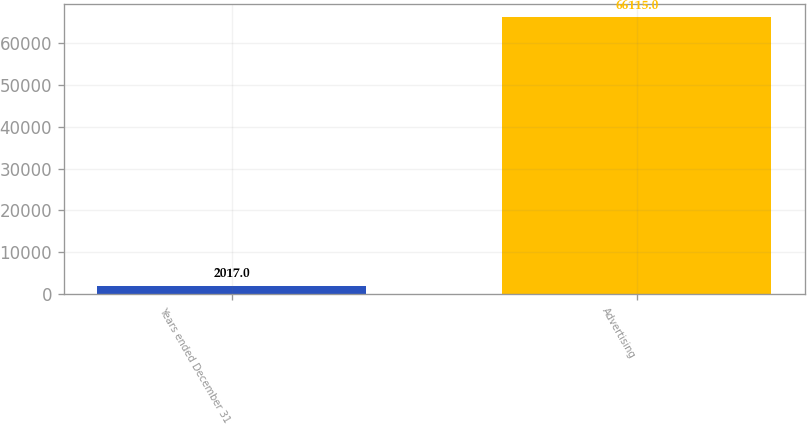Convert chart to OTSL. <chart><loc_0><loc_0><loc_500><loc_500><bar_chart><fcel>Years ended December 31<fcel>Advertising<nl><fcel>2017<fcel>66115<nl></chart> 